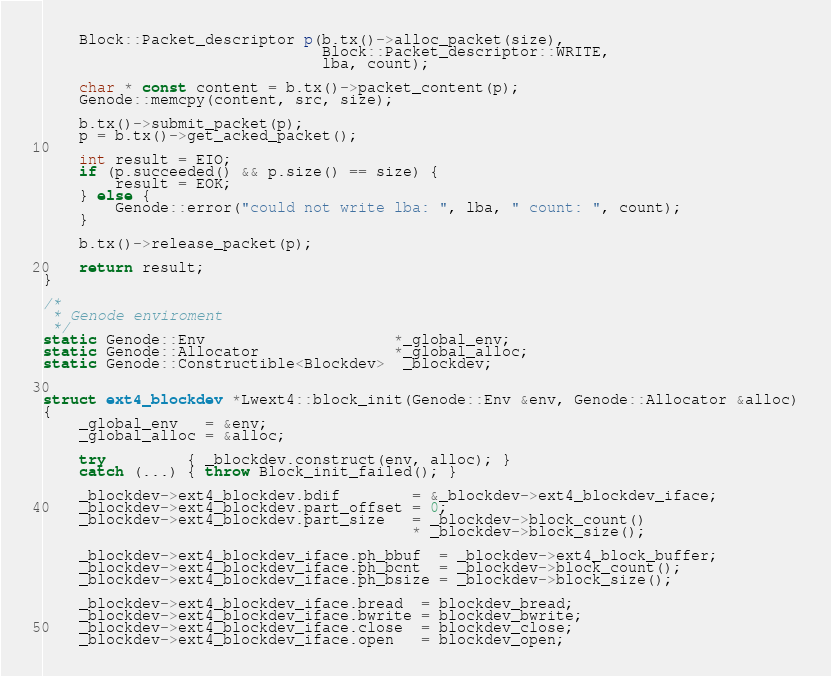Convert code to text. <code><loc_0><loc_0><loc_500><loc_500><_C++_>	Block::Packet_descriptor p(b.tx()->alloc_packet(size),
	                           Block::Packet_descriptor::WRITE,
	                           lba, count);

	char * const content = b.tx()->packet_content(p);
	Genode::memcpy(content, src, size);

	b.tx()->submit_packet(p);
	p = b.tx()->get_acked_packet();

	int result = EIO;
	if (p.succeeded() && p.size() == size) {
		result = EOK;
	} else {
		Genode::error("could not write lba: ", lba, " count: ", count);
	}

	b.tx()->release_packet(p);

	return result;
}

/*
 * Genode enviroment
 */
static Genode::Env                     *_global_env;
static Genode::Allocator               *_global_alloc;
static Genode::Constructible<Blockdev>  _blockdev;


struct ext4_blockdev *Lwext4::block_init(Genode::Env &env, Genode::Allocator &alloc)
{
	_global_env   = &env;
	_global_alloc = &alloc;

	try         { _blockdev.construct(env, alloc); }
	catch (...) { throw Block_init_failed(); }

	_blockdev->ext4_blockdev.bdif        = &_blockdev->ext4_blockdev_iface;
	_blockdev->ext4_blockdev.part_offset = 0;
	_blockdev->ext4_blockdev.part_size   = _blockdev->block_count()
	                                     * _blockdev->block_size();

	_blockdev->ext4_blockdev_iface.ph_bbuf  = _blockdev->ext4_block_buffer;
	_blockdev->ext4_blockdev_iface.ph_bcnt  = _blockdev->block_count();
	_blockdev->ext4_blockdev_iface.ph_bsize = _blockdev->block_size();

	_blockdev->ext4_blockdev_iface.bread  = blockdev_bread;
	_blockdev->ext4_blockdev_iface.bwrite = blockdev_bwrite;
	_blockdev->ext4_blockdev_iface.close  = blockdev_close;
	_blockdev->ext4_blockdev_iface.open   = blockdev_open;
</code> 